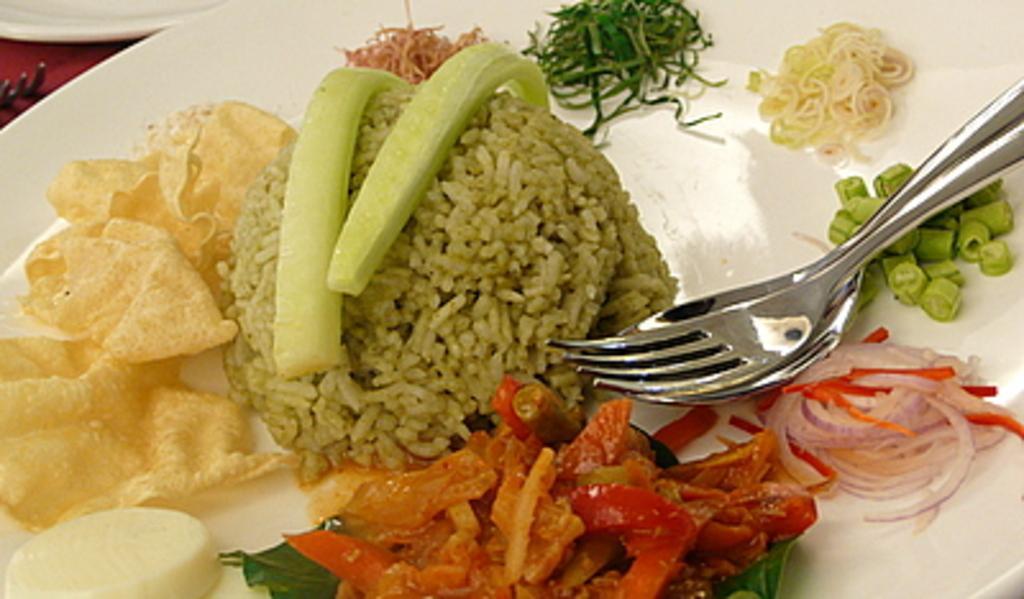Could you give a brief overview of what you see in this image? In the foreground of this image, there are food items on a white platter with a spoon and a fork on it. At the top, there is a platter and a fork. 